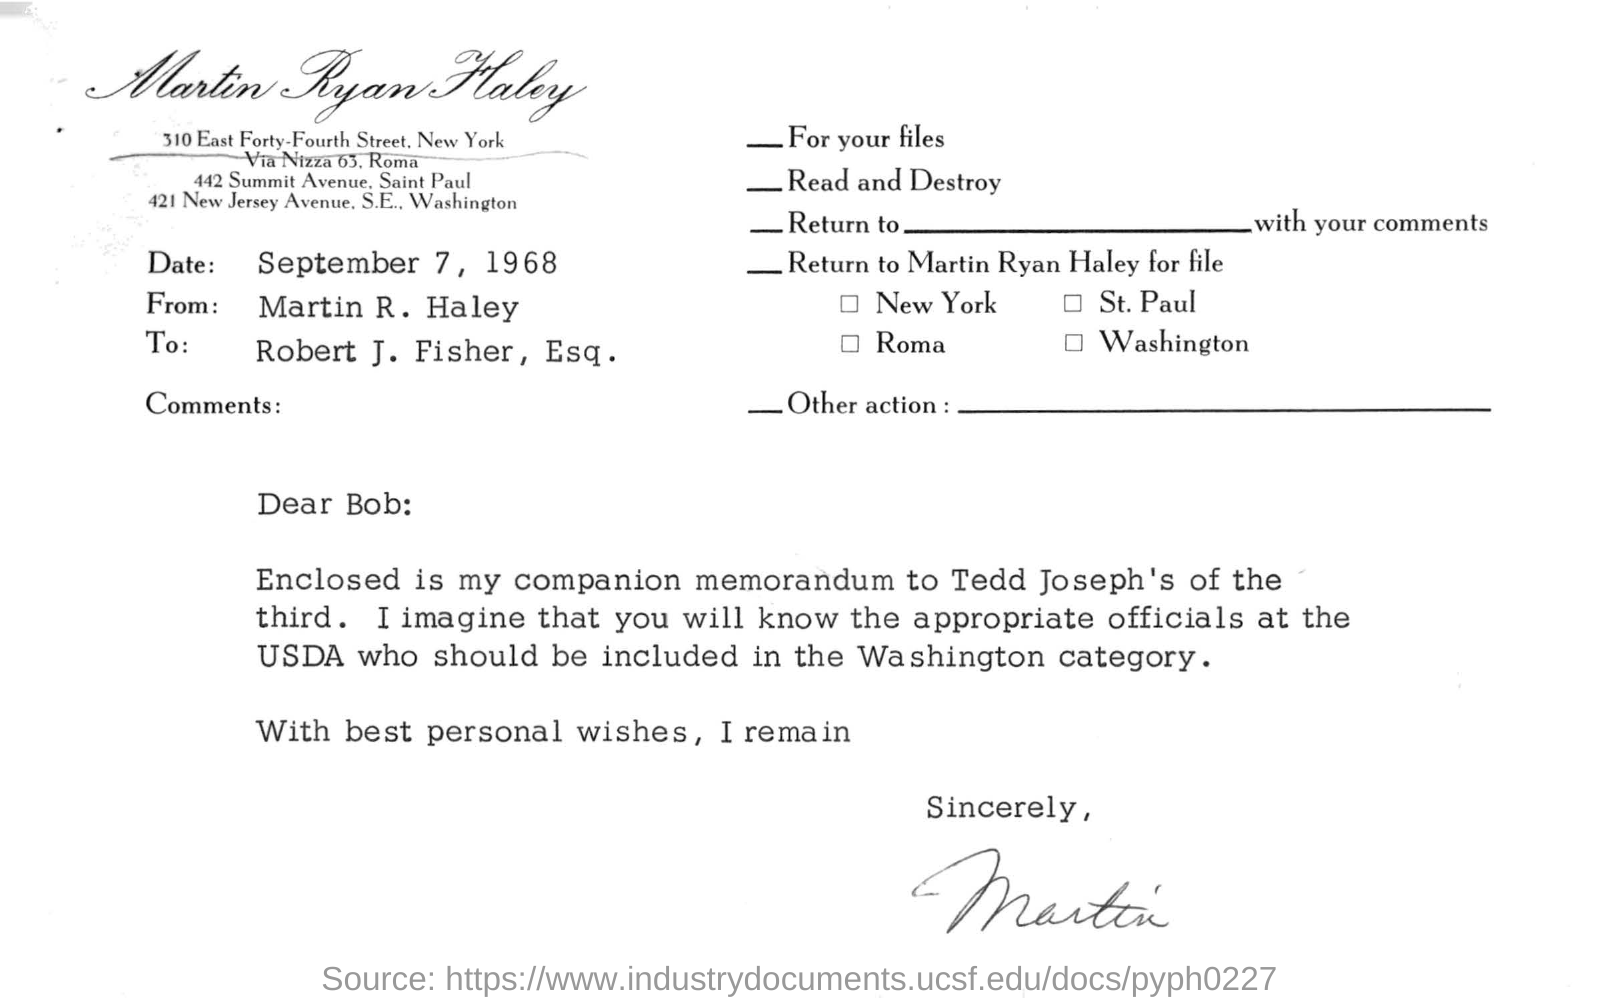Draw attention to some important aspects in this diagram. This letter is from Martin R. Haley. The date mentioned in the letter is September 7, 1968. 